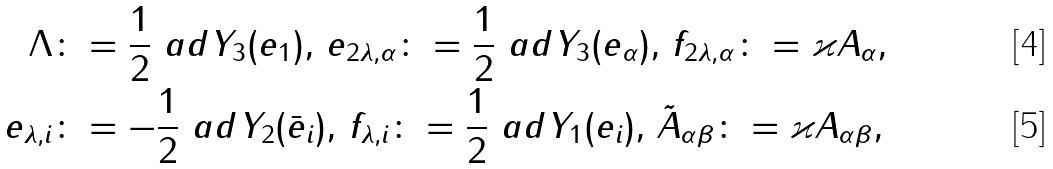<formula> <loc_0><loc_0><loc_500><loc_500>\Lambda & \colon = \frac { 1 } { 2 } \ a d Y _ { 3 } ( e _ { 1 } ) , \, e _ { 2 \lambda , \alpha } \colon = \frac { 1 } { 2 } \ a d Y _ { 3 } ( e _ { \alpha } ) , \, f _ { 2 \lambda , \alpha } \colon = \varkappa A _ { \alpha } , \\ e _ { \lambda , i } & \colon = - \frac { 1 } { 2 } \ a d Y _ { 2 } ( \bar { e } _ { i } ) , \, f _ { \lambda , i } \colon = \frac { 1 } { 2 } \ a d Y _ { 1 } ( e _ { i } ) , \, \tilde { A } _ { \alpha \beta } \colon = \varkappa A _ { \alpha \beta } ,</formula> 